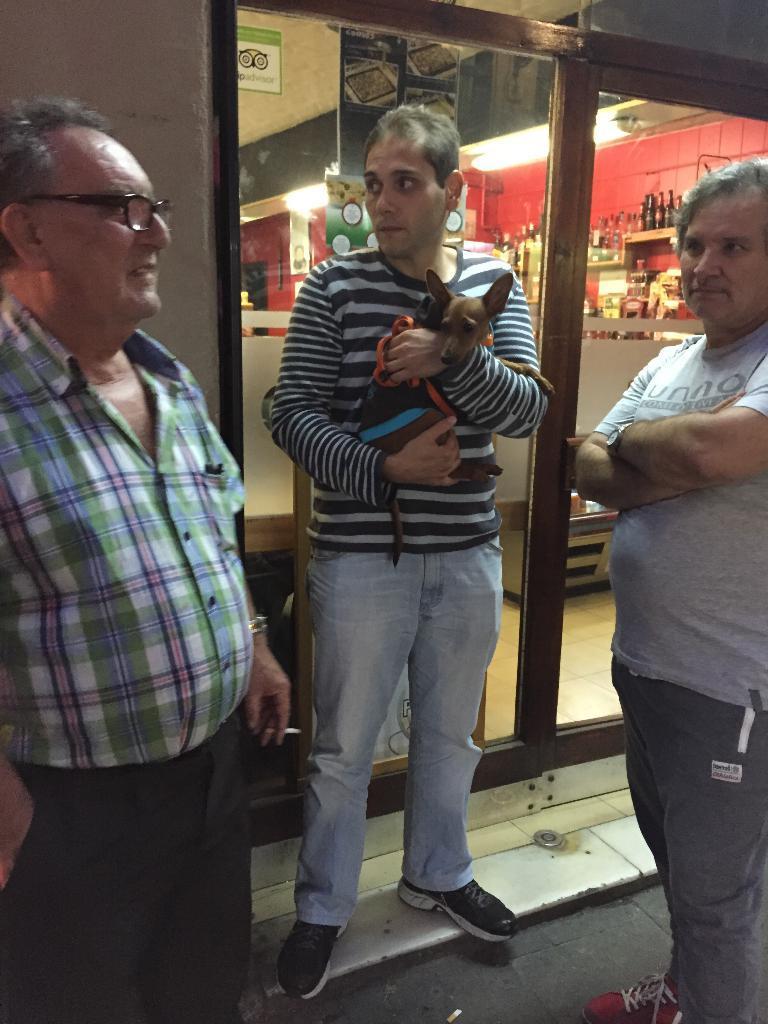Could you give a brief overview of what you see in this image? In this image there are three persons standing in front of the store. Person in the middle holding a dog, he is wearing a black and white t shirt, blue jeans, and black shoes. Person in the right side, he is wearing grey t shirt, grey trousers with red shoes. Person in the left side, he is wearing check shirt, black trousers and spectacles. 